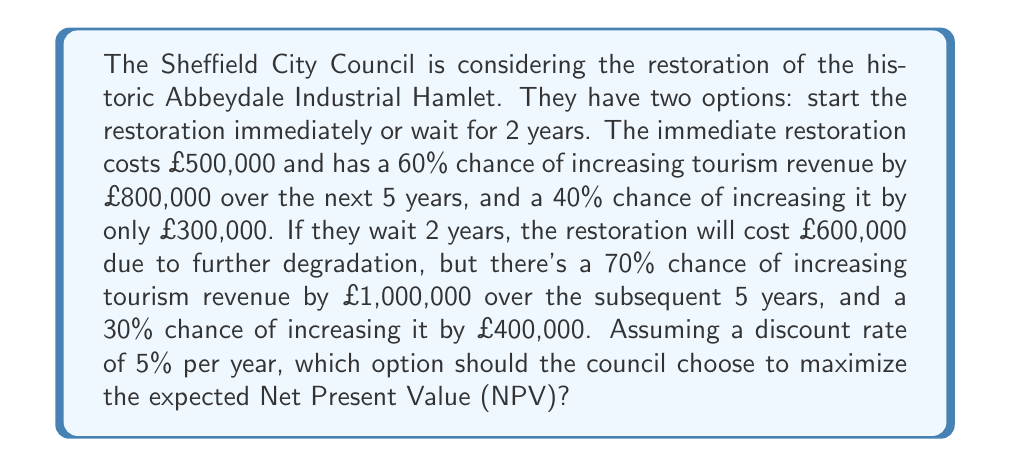What is the answer to this math problem? Let's approach this problem step by step using decision tree analysis:

1. Calculate the NPV for immediate restoration:

   a. For the 60% chance scenario:
      $$NPV = -500,000 + \frac{800,000}{(1 + 0.05)^5} = -500,000 + 626,567 = 126,567$$

   b. For the 40% chance scenario:
      $$NPV = -500,000 + \frac{300,000}{(1 + 0.05)^5} = -500,000 + 234,963 = -265,037$$

   c. Expected NPV for immediate restoration:
      $$E(NPV_{immediate}) = 0.6 \times 126,567 + 0.4 \times (-265,037) = -30,574$$

2. Calculate the NPV for waiting 2 years:

   a. For the 70% chance scenario:
      $$NPV = -\frac{600,000}{(1 + 0.05)^2} + \frac{1,000,000}{(1 + 0.05)^7} = -544,218 + 710,782 = 166,564$$

   b. For the 30% chance scenario:
      $$NPV = -\frac{600,000}{(1 + 0.05)^2} + \frac{400,000}{(1 + 0.05)^7} = -544,218 + 284,313 = -259,905$$

   c. Expected NPV for waiting 2 years:
      $$E(NPV_{wait}) = 0.7 \times 166,564 + 0.3 \times (-259,905) = 38,722$$

3. Compare the expected NPVs:
   
   $E(NPV_{immediate}) = -30,574$
   $E(NPV_{wait}) = 38,722$

Since $E(NPV_{wait}) > E(NPV_{immediate})$, the council should choose to wait 2 years before starting the restoration project to maximize the expected NPV.
Answer: The Sheffield City Council should wait 2 years before starting the restoration project, as this option has a higher expected Net Present Value of £38,722 compared to -£30,574 for immediate restoration. 